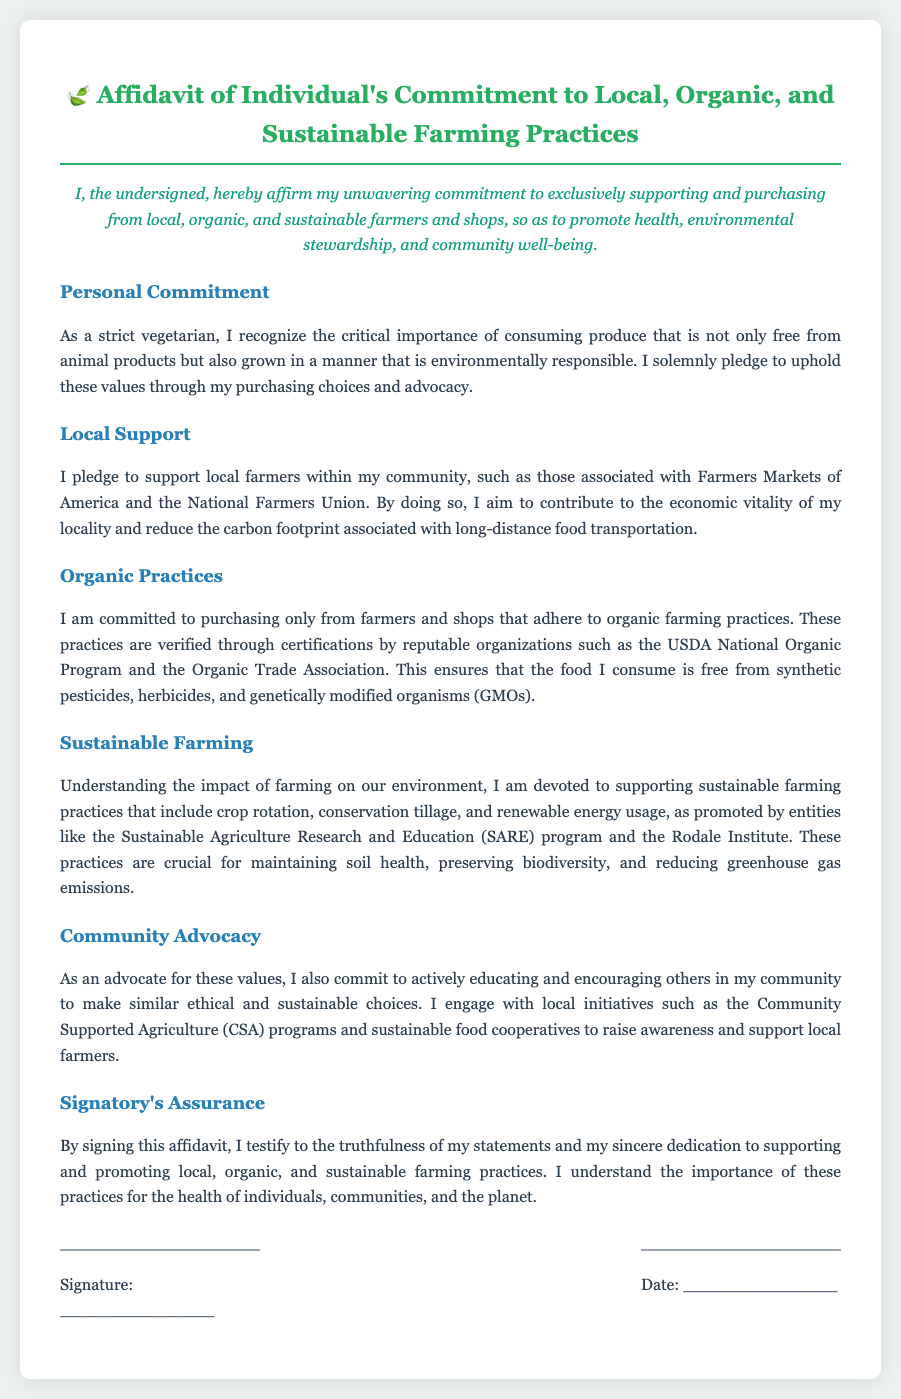What is the title of the document? The title of the document is prominently displayed at the top and states the purpose of the affidavit.
Answer: Affidavit of Individual's Commitment to Local, Organic, and Sustainable Farming Practices Who does the affidavit affirm commitment from? The opening statement indicates the individual who agrees to the terms set forth in the document.
Answer: The undersigned What ethical dietary choice does the individual identify with? The document specifies the dietary restrictions and choices upheld by the individual in their commitment.
Answer: Strict vegetarian What organizations are mentioned in relation to local farmers? The document references specific organizations that support local farming within the community.
Answer: Farmers Markets of America and the National Farmers Union What does the individual pledge to support according to the organic practices section? The section highlights the promise concerning the types of farming practices that must be adhered to by the farmers and shops.
Answer: Organic farming practices What is a sustainable practice mentioned in the document? The individual discusses various sustainable farming practices which are critical for environmental health.
Answer: Crop rotation What community initiative does the individual engage with? The community engagement aspect outlines initiatives that the individual supports to promote sustainable choices.
Answer: Community Supported Agriculture (CSA) programs What is required from the signatory by signing the affidavit? The closing section of the affidavit outlines the commitment and assurance expressed by the signatory.
Answer: Truthfulness of statements What is the color scheme for the main heading? The color styling for headings provides information on document aesthetics, which may hold significance in visual communication.
Answer: Green 